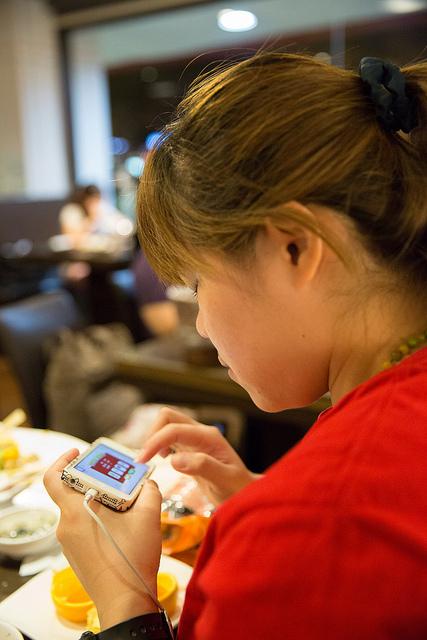What color is the woman's shirt?
Answer briefly. Red. What is on the plate in front of the woman?
Answer briefly. Orange. Is she wearing earrings?
Short answer required. No. What is she holding in her hand?
Short answer required. Phone. 